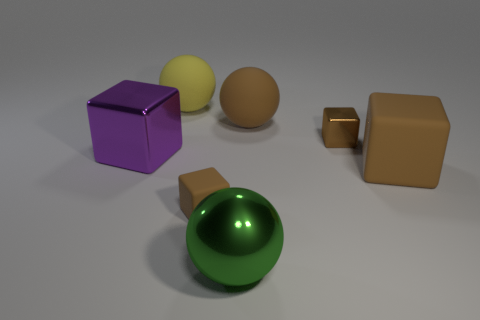How many rubber things are to the left of the green ball?
Provide a short and direct response. 2. Are there an equal number of balls that are right of the small brown matte thing and big objects that are behind the green shiny ball?
Offer a very short reply. No. There is a yellow object that is the same shape as the large green thing; what size is it?
Your response must be concise. Large. There is a brown matte thing that is behind the large brown block; what is its shape?
Give a very brief answer. Sphere. Is the large block left of the big yellow matte thing made of the same material as the large block on the right side of the big yellow thing?
Ensure brevity in your answer.  No. The large yellow thing is what shape?
Offer a very short reply. Sphere. Are there an equal number of green spheres that are on the left side of the tiny rubber cube and brown metallic blocks?
Offer a terse response. No. There is a ball that is the same color as the big rubber cube; what is its size?
Offer a terse response. Large. Is there a yellow object that has the same material as the yellow ball?
Make the answer very short. No. Does the small object that is to the left of the green sphere have the same shape as the metallic thing that is to the right of the green sphere?
Provide a short and direct response. Yes. 